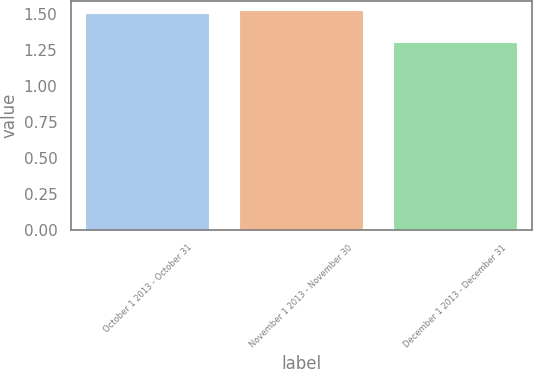Convert chart. <chart><loc_0><loc_0><loc_500><loc_500><bar_chart><fcel>October 1 2013 - October 31<fcel>November 1 2013 - November 30<fcel>December 1 2013 - December 31<nl><fcel>1.5<fcel>1.52<fcel>1.3<nl></chart> 